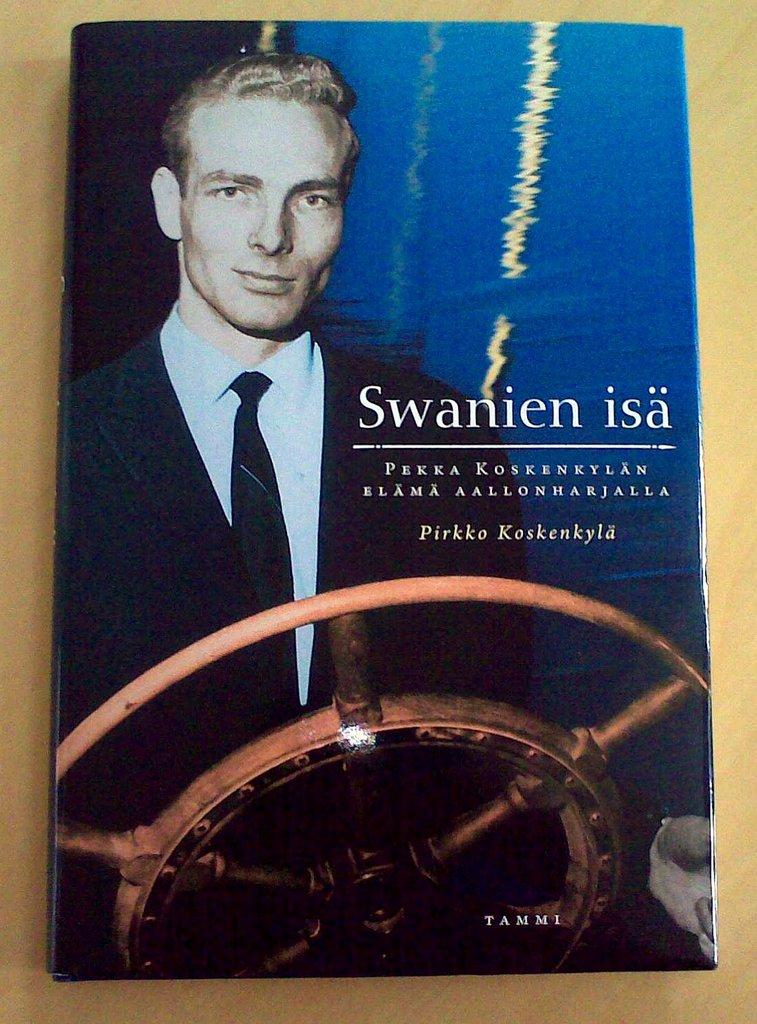Provide a one-sentence caption for the provided image. A book named Swanien isa Pirkko Kaskenkyla is on the table. 